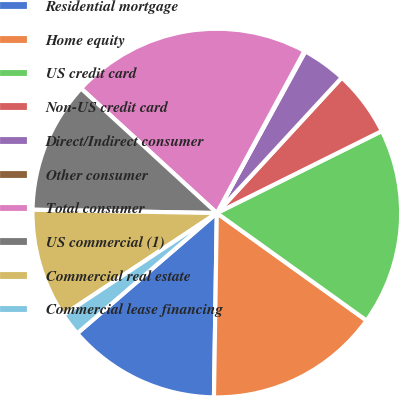Convert chart. <chart><loc_0><loc_0><loc_500><loc_500><pie_chart><fcel>Residential mortgage<fcel>Home equity<fcel>US credit card<fcel>Non-US credit card<fcel>Direct/Indirect consumer<fcel>Other consumer<fcel>Total consumer<fcel>US commercial (1)<fcel>Commercial real estate<fcel>Commercial lease financing<nl><fcel>13.43%<fcel>15.34%<fcel>17.25%<fcel>5.8%<fcel>3.89%<fcel>0.08%<fcel>21.07%<fcel>11.53%<fcel>9.62%<fcel>1.99%<nl></chart> 